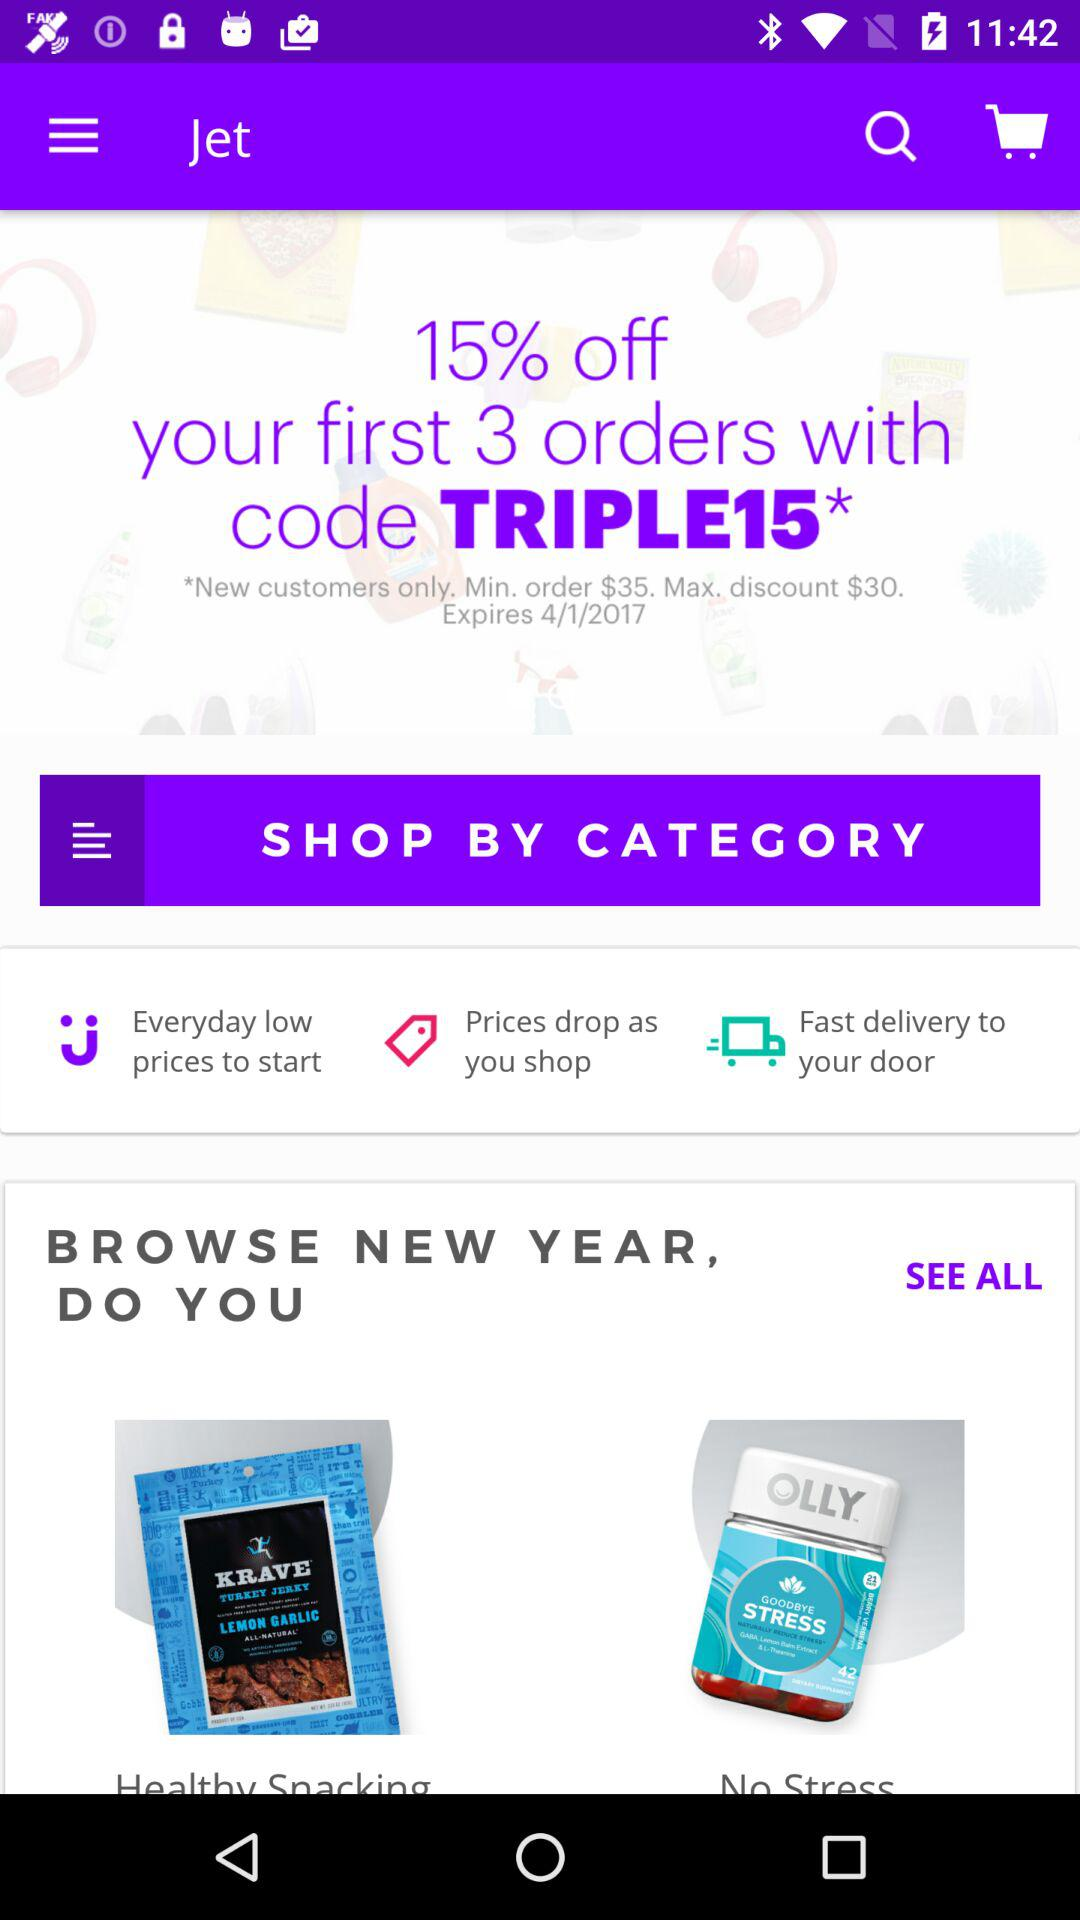How many shopping categories are there?
When the provided information is insufficient, respond with <no answer>. <no answer> 